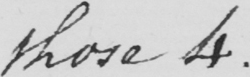Please provide the text content of this handwritten line. those 4. 